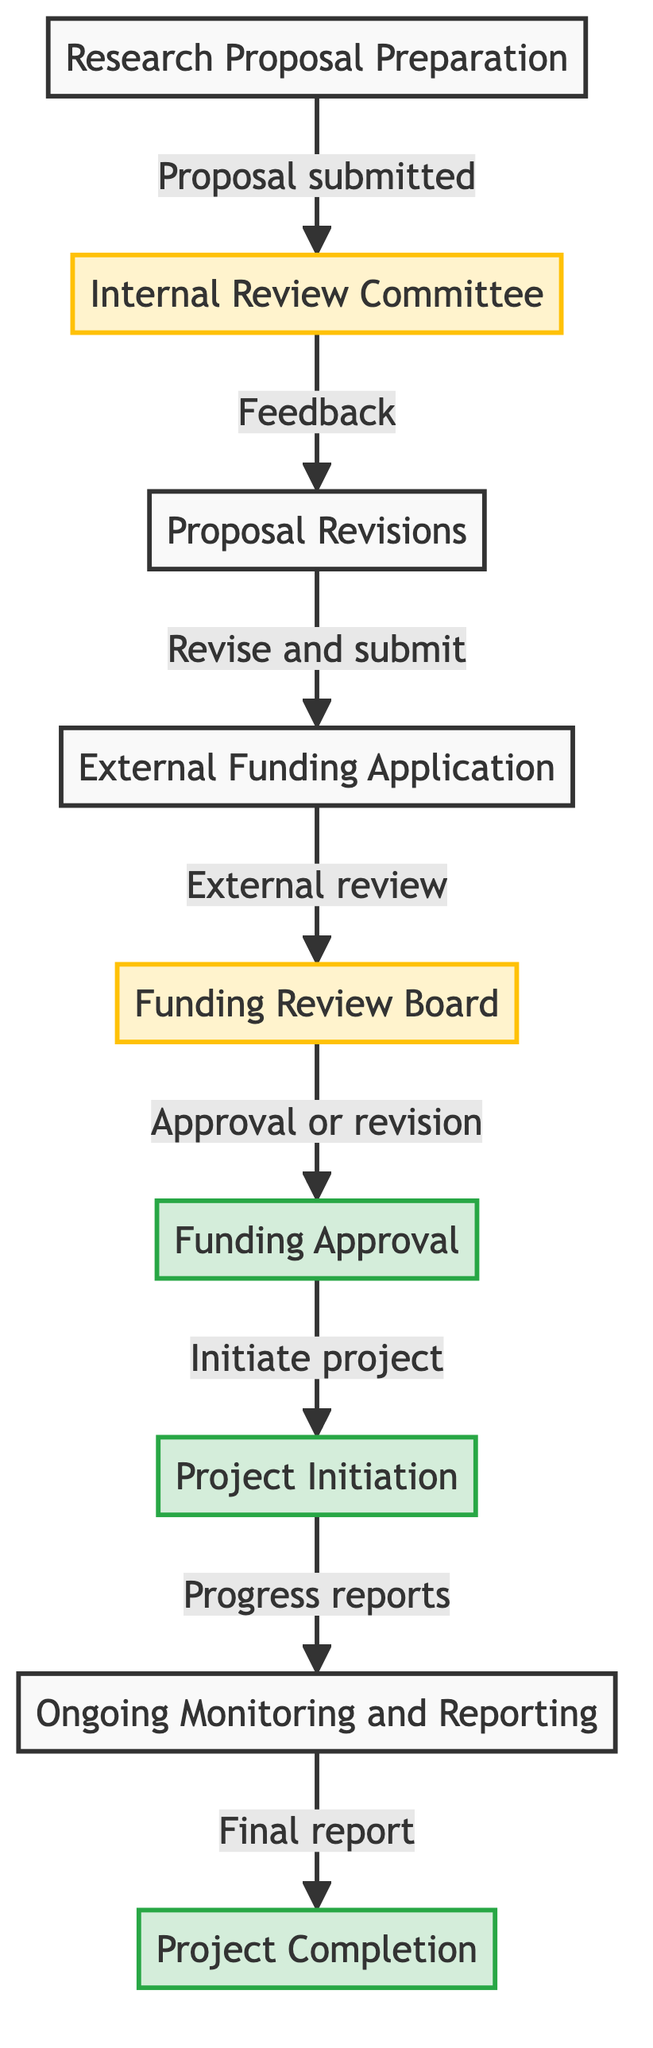What is the first step in the funding allocation process? The diagram indicates that the first step is "Research Proposal Preparation," as it is the initial node in the directed graph.
Answer: Research Proposal Preparation How many nodes are present in the diagram? By counting all the entities depicted in the diagram, there are a total of nine nodes which represent different stages in the funding allocation process.
Answer: 9 What follows after the "Funding Review Board"? Based on the directed edges in the diagram, the node that follows "Funding Review Board" is "Funding Approval."
Answer: Funding Approval What is required before initiating the research project? According to the diagram, "Funding Approval" must be obtained before the "Project Initiation" can occur, as indicated by the directed connection.
Answer: Funding Approval Which node has a feedback role in the process? The "Internal Review Committee" is the node that provides feedback regarding the research proposal, as indicated by the connection to "Proposal Revisions."
Answer: Internal Review Committee How many connections are there leading to the "Project Completion"? By examining the diagram, there is one connection leading directly to "Project Completion," which comes from "Ongoing Monitoring and Reporting."
Answer: 1 What is the result of the external review of the funding application? The diagram shows that the result of the external review conducted by the "Funding Review Board" is either "Funding Approval" or requesting further revisions, represented by the directed edge leading to "Funding Approval."
Answer: Approval or revision In which phase are progress reports submitted? The diagram indicates that "Ongoing Monitoring and Reporting" is the phase during which progress and financial reports are submitted, as shown by the connection to "Project Initiation."
Answer: Ongoing Monitoring and Reporting What happens after the "Project Initiation"? Following "Project Initiation," the next step in the diagram is "Ongoing Monitoring and Reporting," which shows the subsequent phase of the funding allocation process.
Answer: Ongoing Monitoring and Reporting 